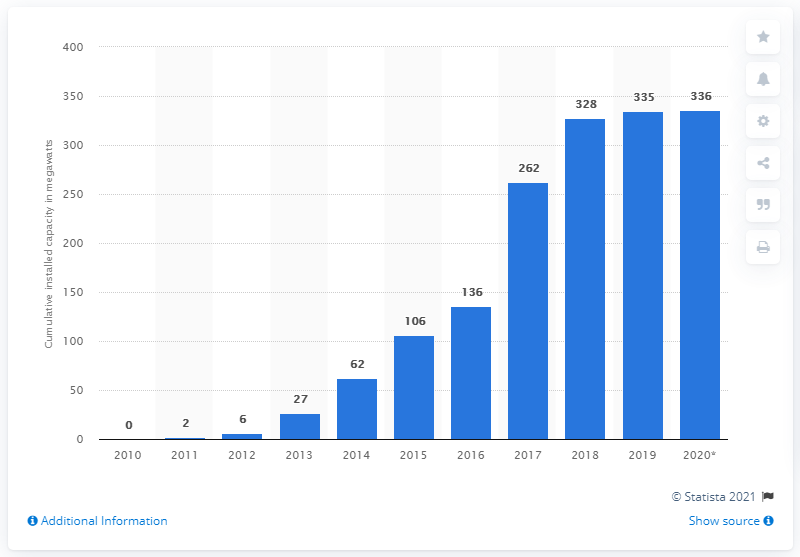Mention a couple of crucial points in this snapshot. Northern Ireland's solar capacity in 2011 was approximately 2 megawatts. As of 2021, the installed solar photovoltaic (PV) capacity in Northern Ireland is approximately 336 megawatts (MW). 